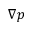Convert formula to latex. <formula><loc_0><loc_0><loc_500><loc_500>\nabla p</formula> 